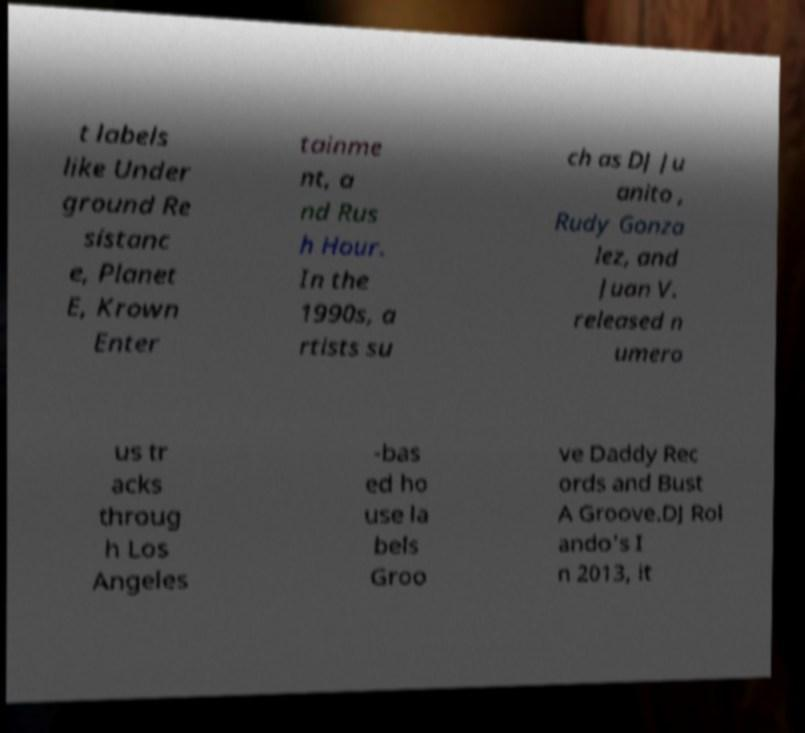I need the written content from this picture converted into text. Can you do that? t labels like Under ground Re sistanc e, Planet E, Krown Enter tainme nt, a nd Rus h Hour. In the 1990s, a rtists su ch as DJ Ju anito , Rudy Gonza lez, and Juan V. released n umero us tr acks throug h Los Angeles -bas ed ho use la bels Groo ve Daddy Rec ords and Bust A Groove.DJ Rol ando's I n 2013, it 